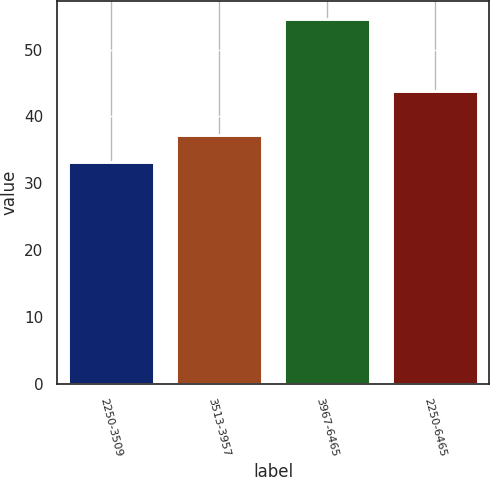Convert chart to OTSL. <chart><loc_0><loc_0><loc_500><loc_500><bar_chart><fcel>2250-3509<fcel>3513-3957<fcel>3967-6465<fcel>2250-6465<nl><fcel>33.2<fcel>37.22<fcel>54.56<fcel>43.79<nl></chart> 